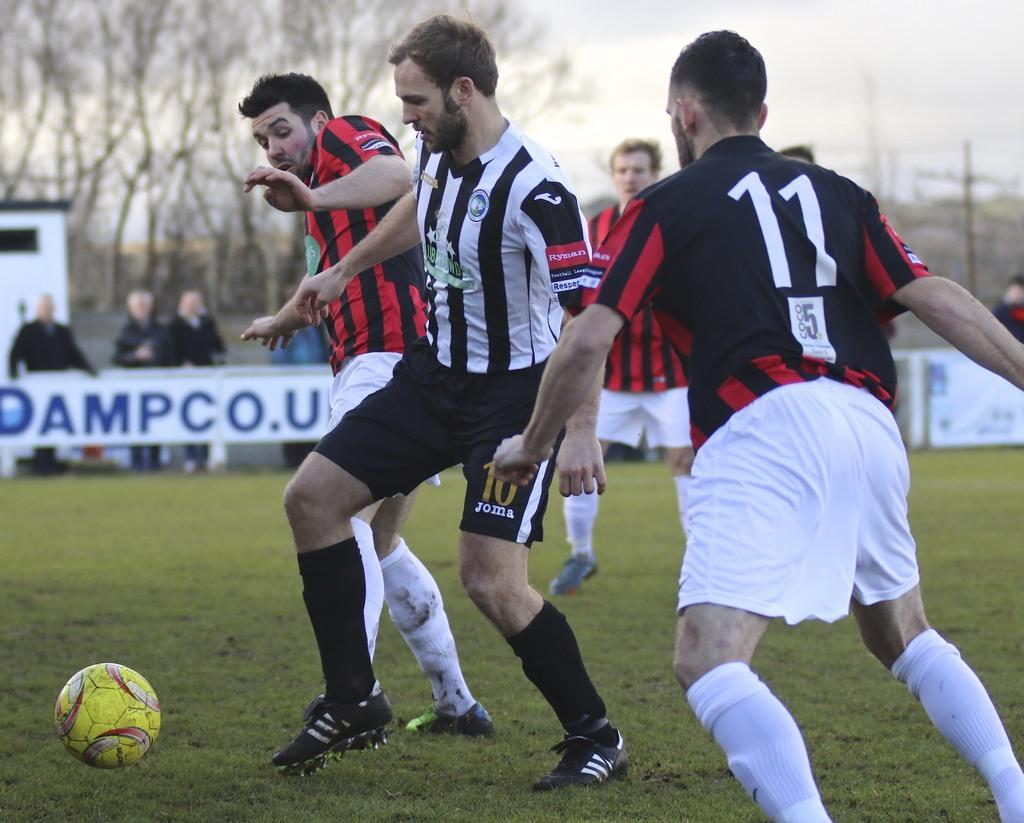<image>
Describe the image concisely. Soccer players on the field in front of a banner with Dampco.u on it in blue. 